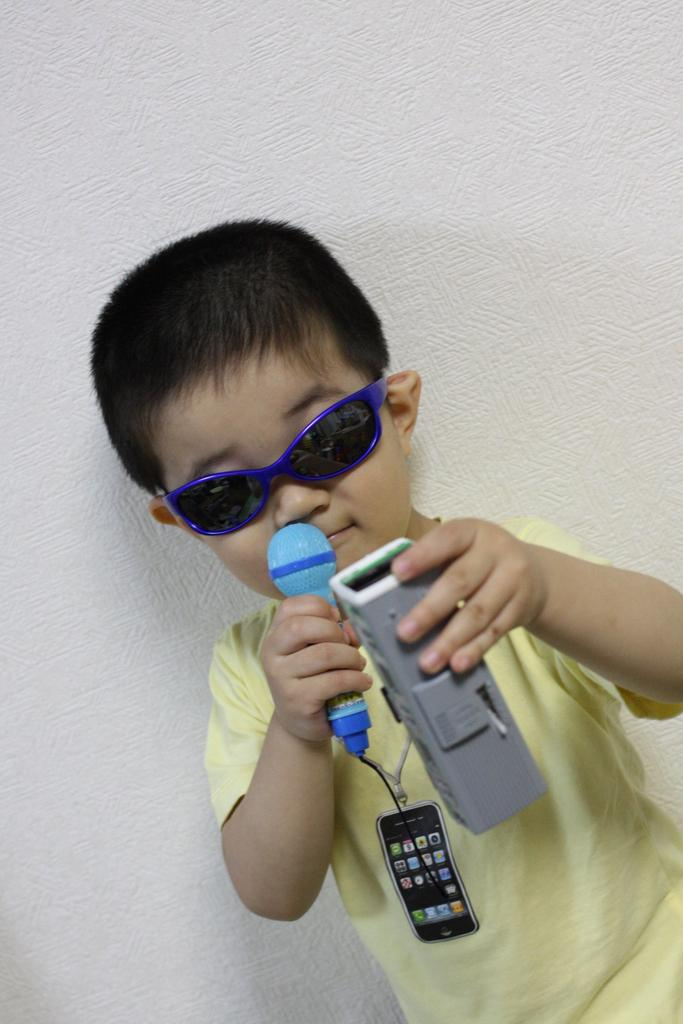Who is the main subject in the image? There is a boy in the image. What is the boy wearing on his face? The boy is wearing goggles. What is the boy holding in his hand? The boy is holding a blue microphone. What is the color of the wall behind the boy? There is a white wall behind the boy. How much salt is on the road in the image? There is no salt or road present in the image. 